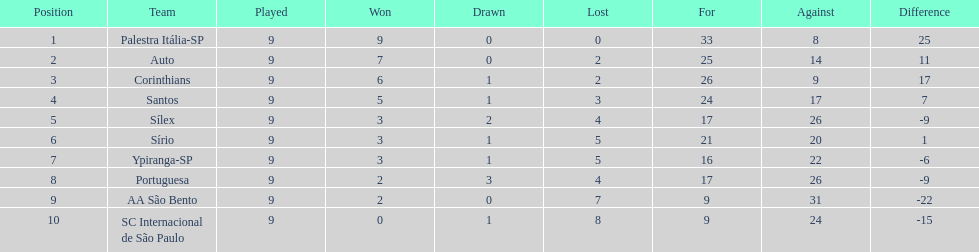Which is the only team to score 13 points in 9 games? Corinthians. 